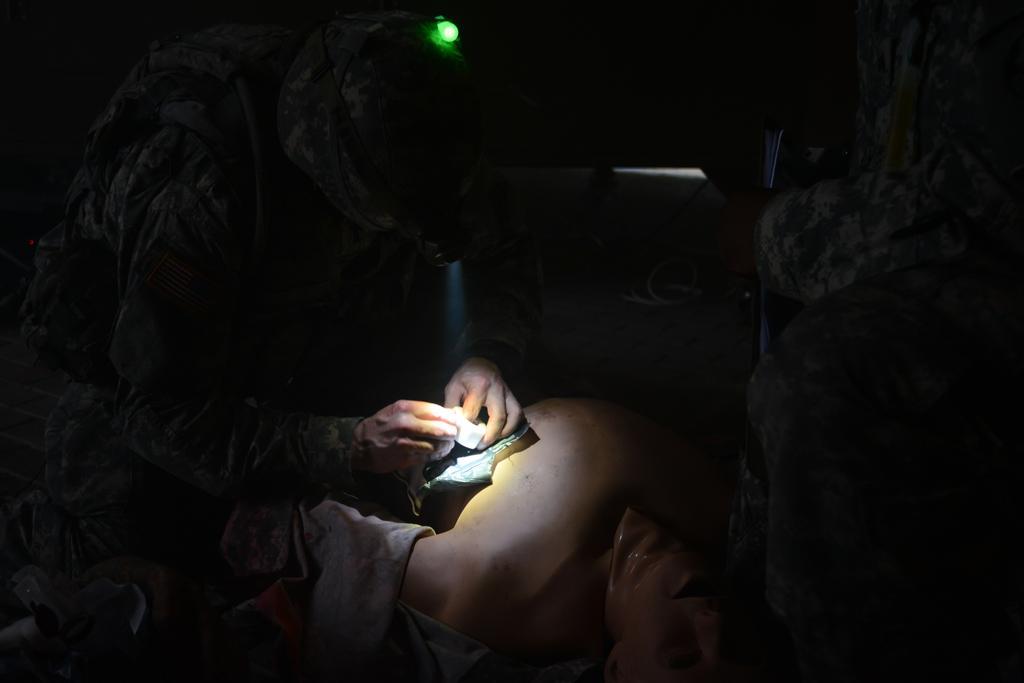Describe this image in one or two sentences. In this image, we can see a person wearing uniform, a bag, a headlamp and holding some objects. In the background, there is a rock wall and some other objects. 